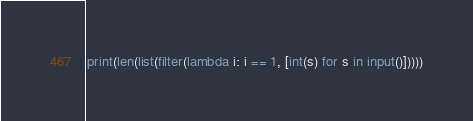<code> <loc_0><loc_0><loc_500><loc_500><_Python_>print(len(list(filter(lambda i: i == 1, [int(s) for s in input()]))))</code> 